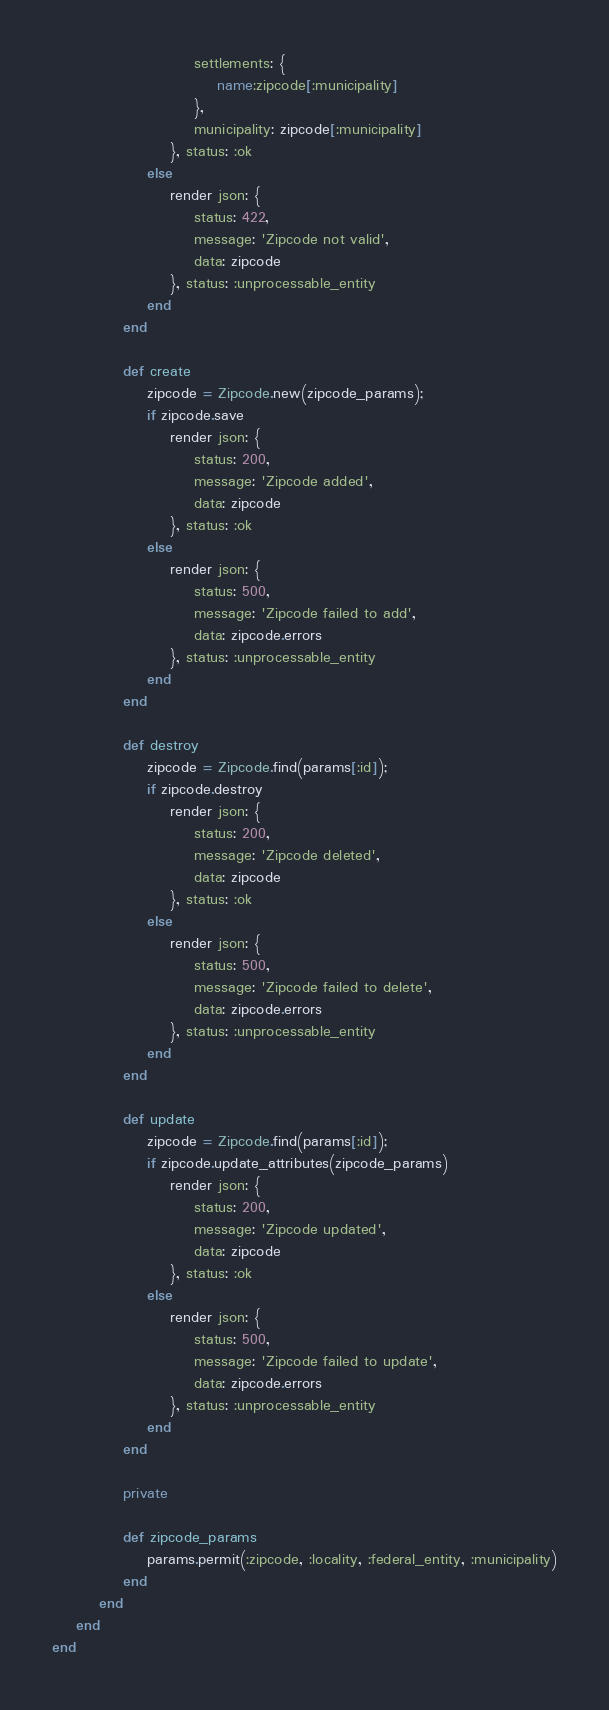Convert code to text. <code><loc_0><loc_0><loc_500><loc_500><_Ruby_>                        settlements: {
                            name:zipcode[:municipality]
                        },
                        municipality: zipcode[:municipality]
                    }, status: :ok
                else
                    render json: {
                        status: 422,
                        message: 'Zipcode not valid',
                        data: zipcode
                    }, status: :unprocessable_entity
                end
            end

            def create
                zipcode = Zipcode.new(zipcode_params);
                if zipcode.save
                    render json: {
                        status: 200,
                        message: 'Zipcode added',
                        data: zipcode
                    }, status: :ok
                else
                    render json: {
                        status: 500,
                        message: 'Zipcode failed to add',
                        data: zipcode.errors
                    }, status: :unprocessable_entity
                end
            end

            def destroy
                zipcode = Zipcode.find(params[:id]);
                if zipcode.destroy
                    render json: {
                        status: 200,
                        message: 'Zipcode deleted',
                        data: zipcode
                    }, status: :ok
                else
                    render json: {
                        status: 500,
                        message: 'Zipcode failed to delete',
                        data: zipcode.errors
                    }, status: :unprocessable_entity
                end
            end

            def update
                zipcode = Zipcode.find(params[:id]);
                if zipcode.update_attributes(zipcode_params)
                    render json: {
                        status: 200,
                        message: 'Zipcode updated',
                        data: zipcode
                    }, status: :ok
                else
                    render json: {
                        status: 500,
                        message: 'Zipcode failed to update',
                        data: zipcode.errors
                    }, status: :unprocessable_entity
                end
            end

            private
            
            def zipcode_params
                params.permit(:zipcode, :locality, :federal_entity, :municipality)
            end
        end
    end
end
</code> 